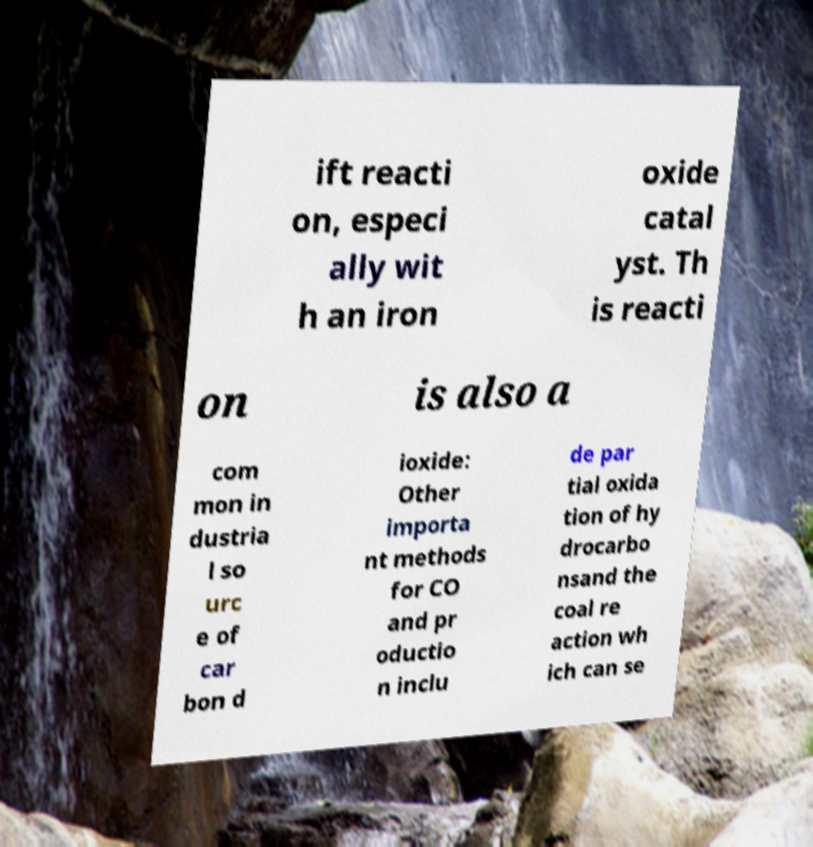Could you extract and type out the text from this image? ift reacti on, especi ally wit h an iron oxide catal yst. Th is reacti on is also a com mon in dustria l so urc e of car bon d ioxide: Other importa nt methods for CO and pr oductio n inclu de par tial oxida tion of hy drocarbo nsand the coal re action wh ich can se 